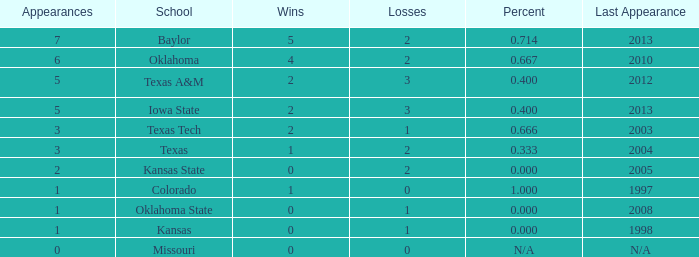How many successful games did baylor achieve? 1.0. 